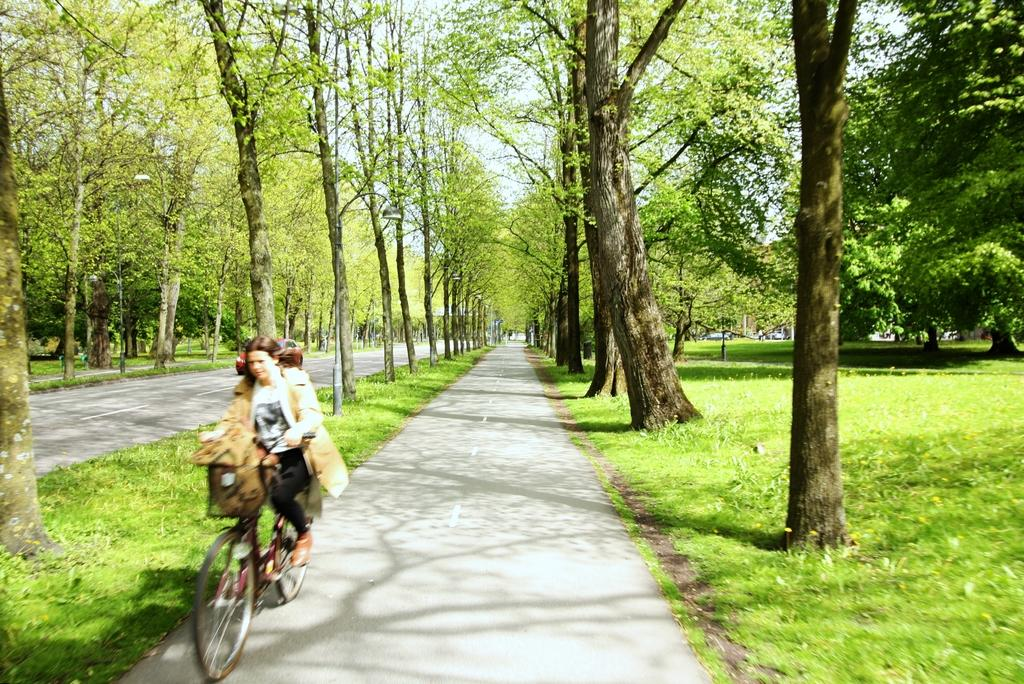Who is the main subject in the image? There is a woman in the image. What is the woman doing in the image? The woman is riding a bicycle. What is located behind the woman in the image? There is a car behind the woman. What type of natural environment can be seen in the image? There are trees visible in the image. What is visible above the woman and the car in the image? The sky is visible in the image. Can you tell me how many fish are swimming in the image? There are no fish present in the image. What type of needle is being used by the woman in the image? There is no needle present in the image, and the woman is riding a bicycle, not using a needle. 